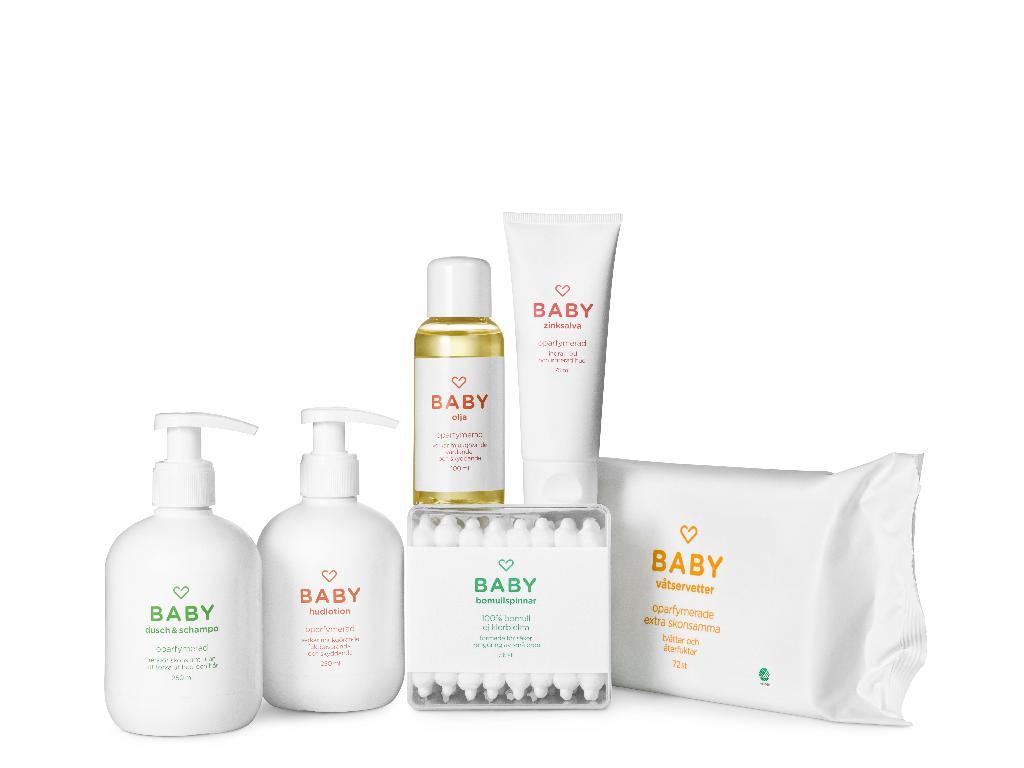What brand is this?
Give a very brief answer. Baby. 